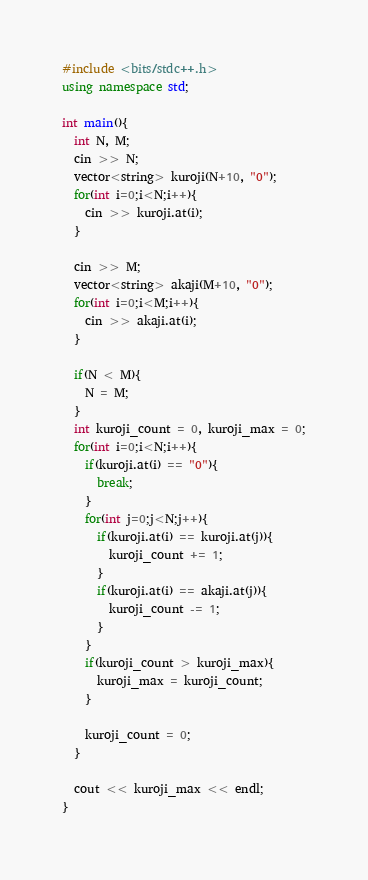<code> <loc_0><loc_0><loc_500><loc_500><_C++_>#include <bits/stdc++.h>
using namespace std;

int main(){
  int N, M;
  cin >> N;
  vector<string> kuroji(N+10, "0");
  for(int i=0;i<N;i++){
    cin >> kuroji.at(i);
  }
  
  cin >> M;
  vector<string> akaji(M+10, "0");
  for(int i=0;i<M;i++){
    cin >> akaji.at(i);
  }
  
  if(N < M){
    N = M;
  }
  int kuroji_count = 0, kuroji_max = 0;
  for(int i=0;i<N;i++){
    if(kuroji.at(i) == "0"){
      break;
    }
    for(int j=0;j<N;j++){
      if(kuroji.at(i) == kuroji.at(j)){
        kuroji_count += 1;
      }
      if(kuroji.at(i) == akaji.at(j)){
        kuroji_count -= 1;
      }
    }
    if(kuroji_count > kuroji_max){
      kuroji_max = kuroji_count;
    }
    
    kuroji_count = 0;
  }
  
  cout << kuroji_max << endl;
}</code> 